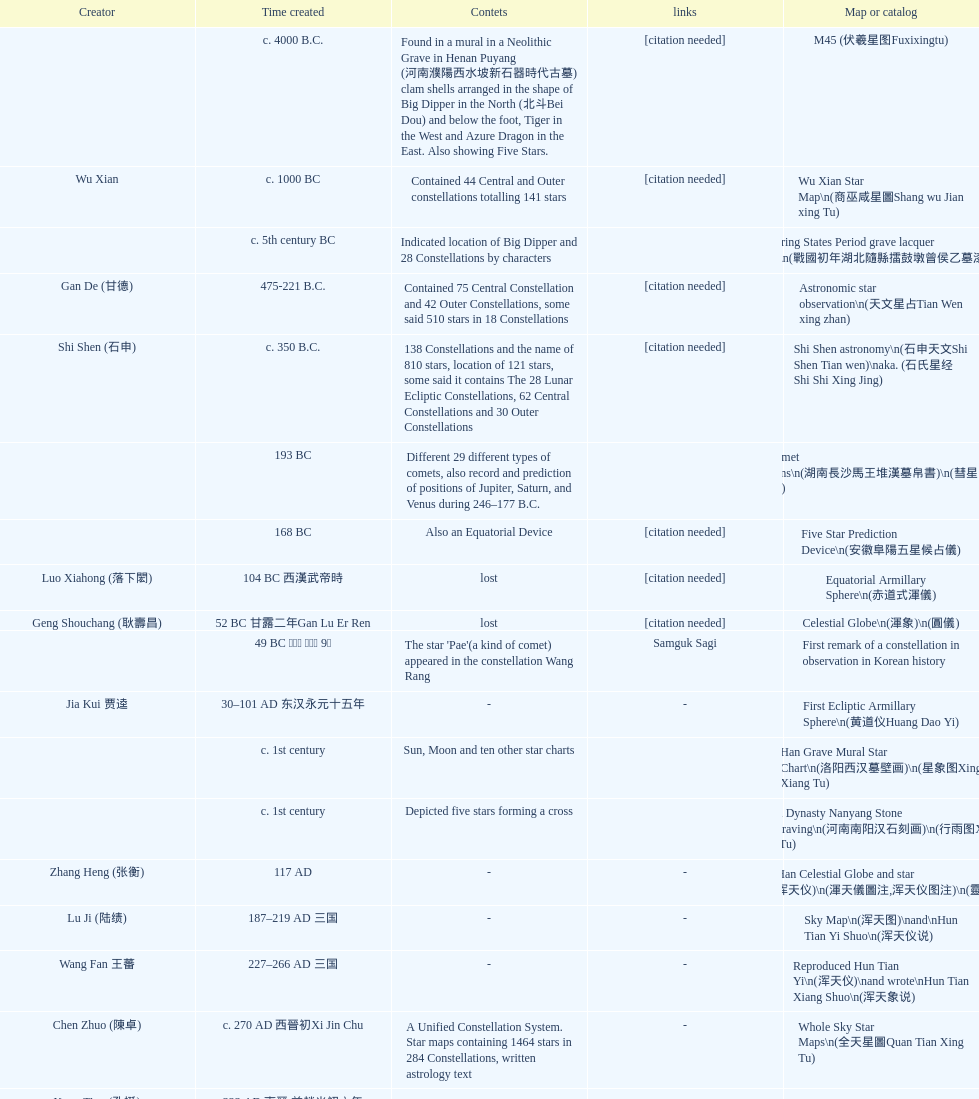What is the difference between the five star prediction device's date of creation and the han comet diagrams' date of creation? 25 years. 